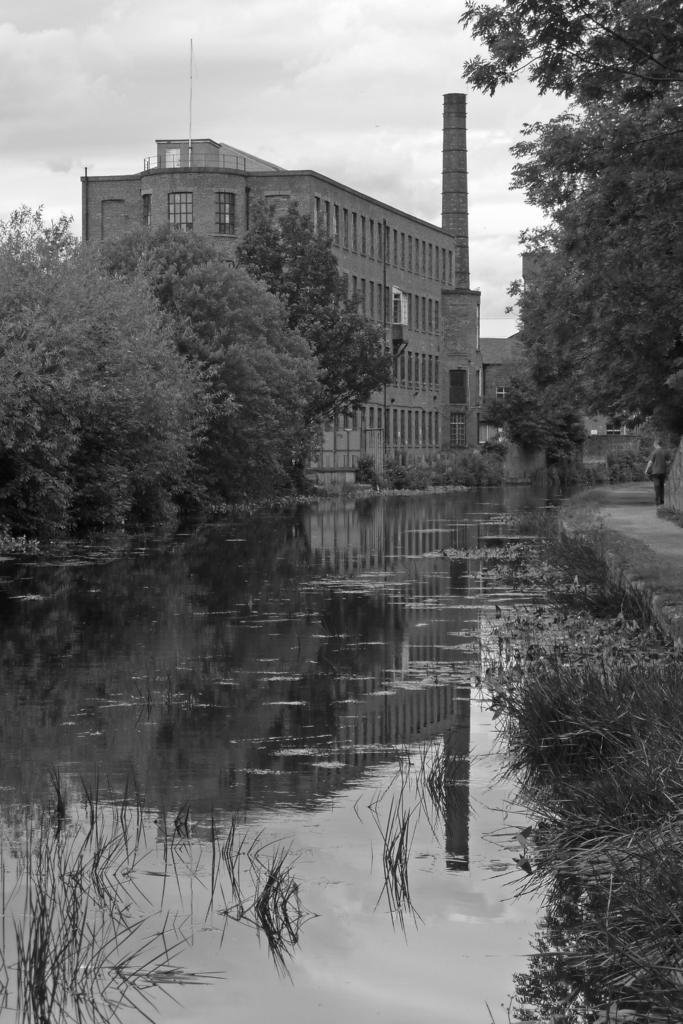What is the color scheme of the image? The image is in black and white. What can be seen in the foreground of the image? There is a man standing on a path. What is located on the left side of the man? There is water, plants, trees, and buildings on the left side of the man. What part of the natural environment is visible in the image? The sky is visible in the image. What type of bead is being used to decorate the toys on the seashore in the image? There is no seashore, toys, or beads present in the image; it features a man standing on a path with various elements on the left side and a visible sky. 